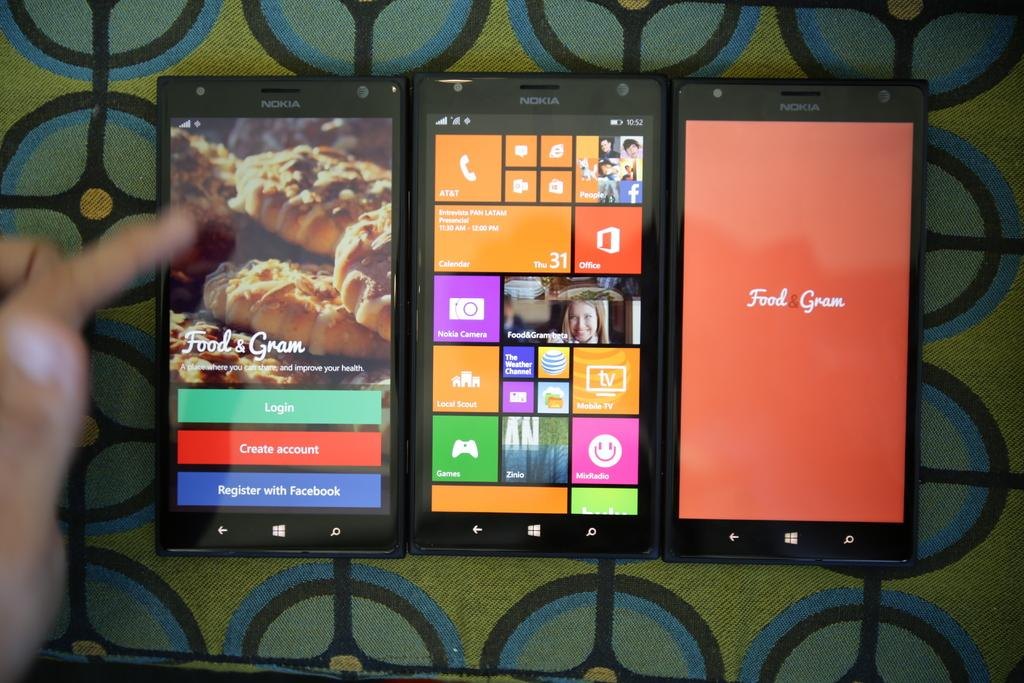<image>
Present a compact description of the photo's key features. three nokia phones and all of them have something that has food & gram on it 